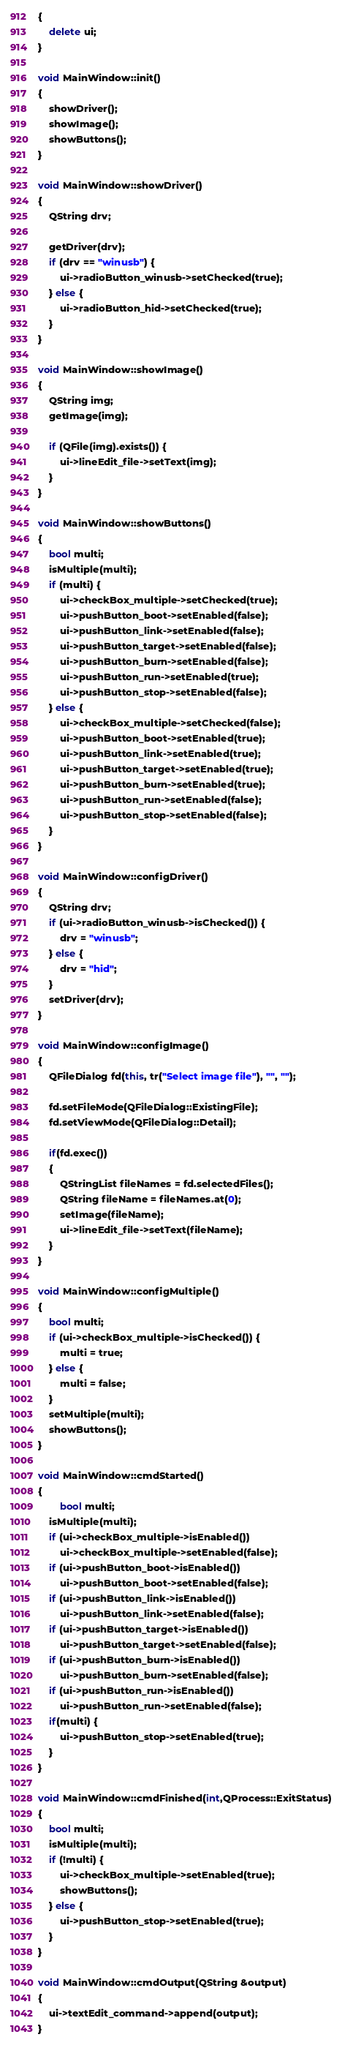Convert code to text. <code><loc_0><loc_0><loc_500><loc_500><_C++_>{
    delete ui;
}

void MainWindow::init()
{
    showDriver();
    showImage();
    showButtons();
}

void MainWindow::showDriver()
{
    QString drv;

    getDriver(drv);
    if (drv == "winusb") {
        ui->radioButton_winusb->setChecked(true);
    } else {
        ui->radioButton_hid->setChecked(true);
    }
}

void MainWindow::showImage()
{
    QString img;
    getImage(img);

    if (QFile(img).exists()) {
        ui->lineEdit_file->setText(img);
    }
}

void MainWindow::showButtons()
{
    bool multi;
    isMultiple(multi);
    if (multi) {
        ui->checkBox_multiple->setChecked(true);
        ui->pushButton_boot->setEnabled(false);
        ui->pushButton_link->setEnabled(false);
        ui->pushButton_target->setEnabled(false);
        ui->pushButton_burn->setEnabled(false);
        ui->pushButton_run->setEnabled(true);
        ui->pushButton_stop->setEnabled(false);
    } else {
        ui->checkBox_multiple->setChecked(false);
        ui->pushButton_boot->setEnabled(true);
        ui->pushButton_link->setEnabled(true);
        ui->pushButton_target->setEnabled(true);
        ui->pushButton_burn->setEnabled(true);
        ui->pushButton_run->setEnabled(false);
        ui->pushButton_stop->setEnabled(false);
    }
}

void MainWindow::configDriver()
{
    QString drv;
    if (ui->radioButton_winusb->isChecked()) {
        drv = "winusb";
    } else {
        drv = "hid";
    }
    setDriver(drv);
}

void MainWindow::configImage()
{
    QFileDialog fd(this, tr("Select image file"), "", "");

    fd.setFileMode(QFileDialog::ExistingFile);
    fd.setViewMode(QFileDialog::Detail);

    if(fd.exec())
    {
        QStringList fileNames = fd.selectedFiles();
        QString fileName = fileNames.at(0);
        setImage(fileName);
        ui->lineEdit_file->setText(fileName);
    }
}

void MainWindow::configMultiple()
{
    bool multi;
    if (ui->checkBox_multiple->isChecked()) {
        multi = true;
    } else {
        multi = false;
    }
    setMultiple(multi);
    showButtons();
}

void MainWindow::cmdStarted()
{
        bool multi;
    isMultiple(multi);
    if (ui->checkBox_multiple->isEnabled())
        ui->checkBox_multiple->setEnabled(false);
    if (ui->pushButton_boot->isEnabled())
        ui->pushButton_boot->setEnabled(false);
    if (ui->pushButton_link->isEnabled())
        ui->pushButton_link->setEnabled(false);
    if (ui->pushButton_target->isEnabled())
        ui->pushButton_target->setEnabled(false);
    if (ui->pushButton_burn->isEnabled())
        ui->pushButton_burn->setEnabled(false);
    if (ui->pushButton_run->isEnabled())
        ui->pushButton_run->setEnabled(false);
    if(multi) {
        ui->pushButton_stop->setEnabled(true);
    }
}

void MainWindow::cmdFinished(int,QProcess::ExitStatus)
{
    bool multi;
    isMultiple(multi);
    if (!multi) {
        ui->checkBox_multiple->setEnabled(true);
        showButtons();
    } else {
        ui->pushButton_stop->setEnabled(true);
    }
}

void MainWindow::cmdOutput(QString &output)
{
    ui->textEdit_command->append(output);
}
</code> 